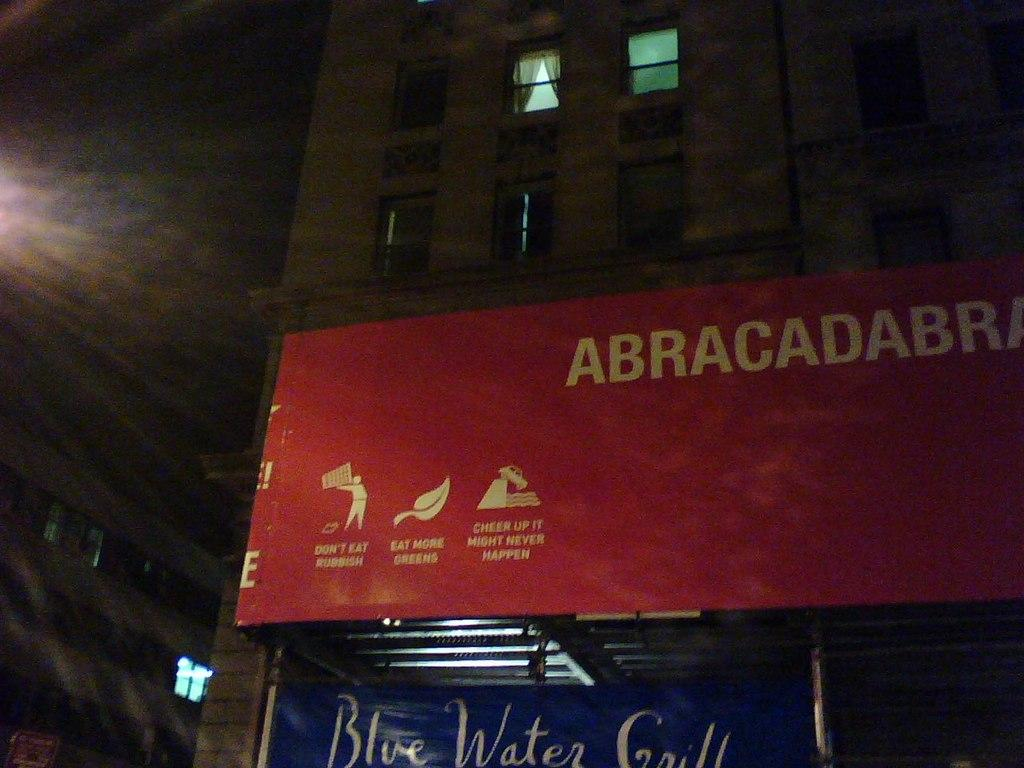<image>
Offer a succinct explanation of the picture presented. Red banner strung across the building front stating "Abracadabra" and "Don't eat rubbish, eat more greens, cheer up it might never happen". 